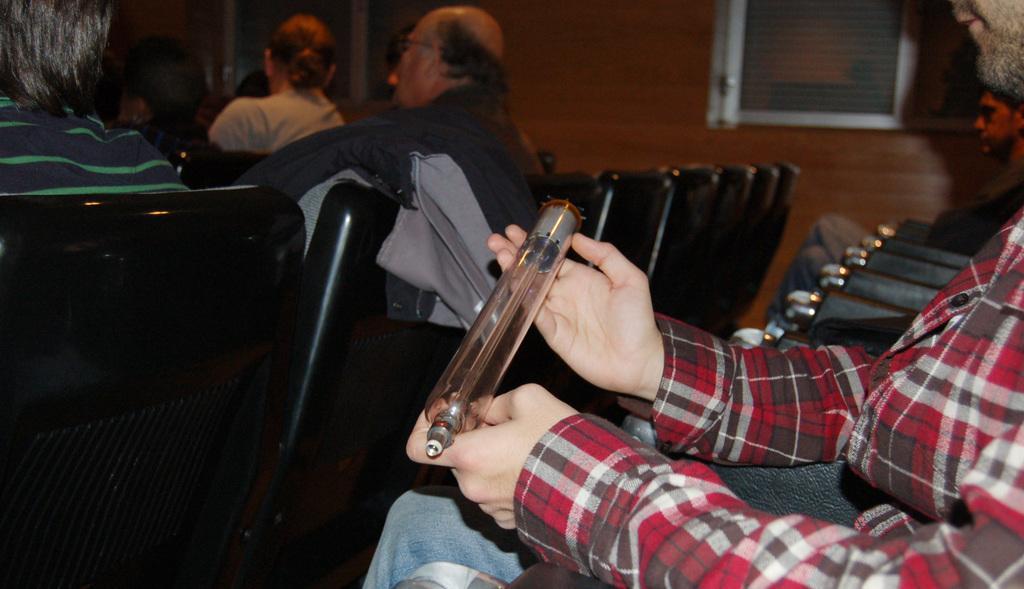Could you give a brief overview of what you see in this image? In this picture there are chairs, in the cars there are people sitting. In the background there are windows and a wall. The background is blurred. 